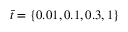Convert formula to latex. <formula><loc_0><loc_0><loc_500><loc_500>\bar { t } = \{ 0 . 0 1 , 0 . 1 , 0 . 3 , 1 \}</formula> 